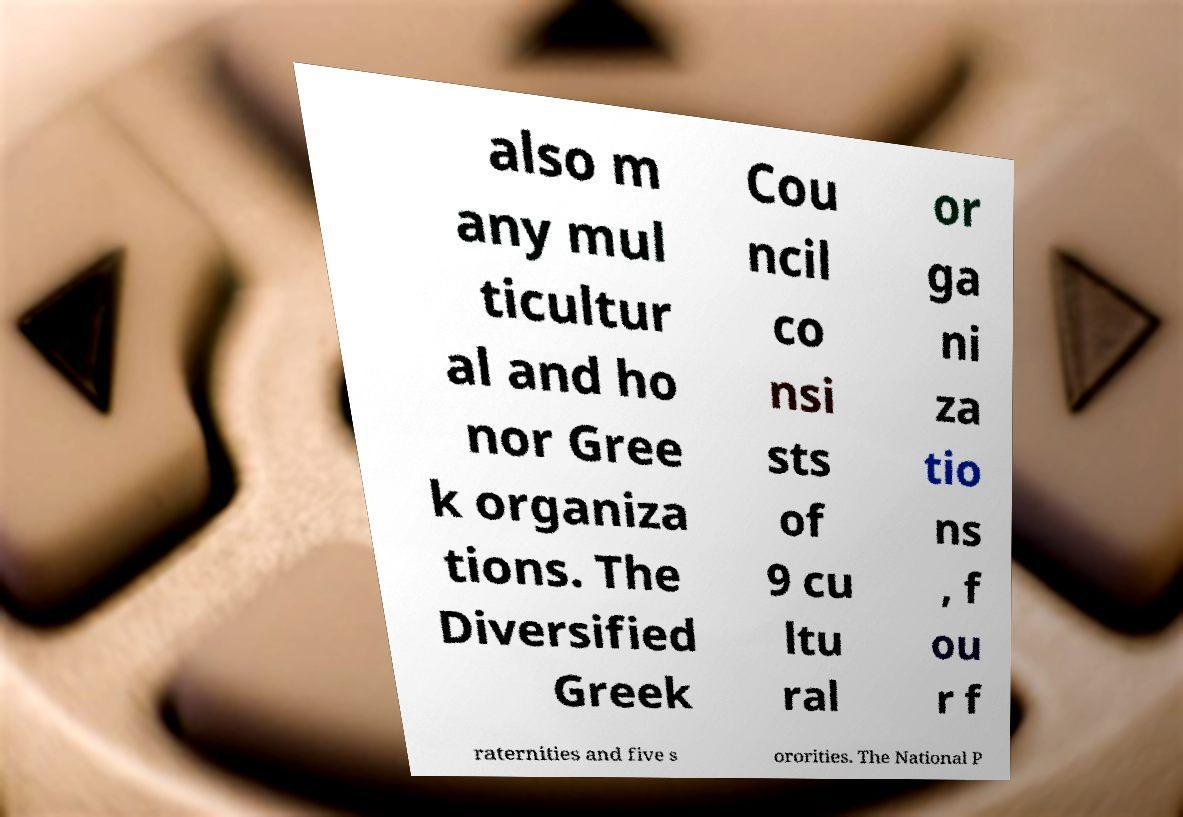Can you accurately transcribe the text from the provided image for me? also m any mul ticultur al and ho nor Gree k organiza tions. The Diversified Greek Cou ncil co nsi sts of 9 cu ltu ral or ga ni za tio ns , f ou r f raternities and five s ororities. The National P 